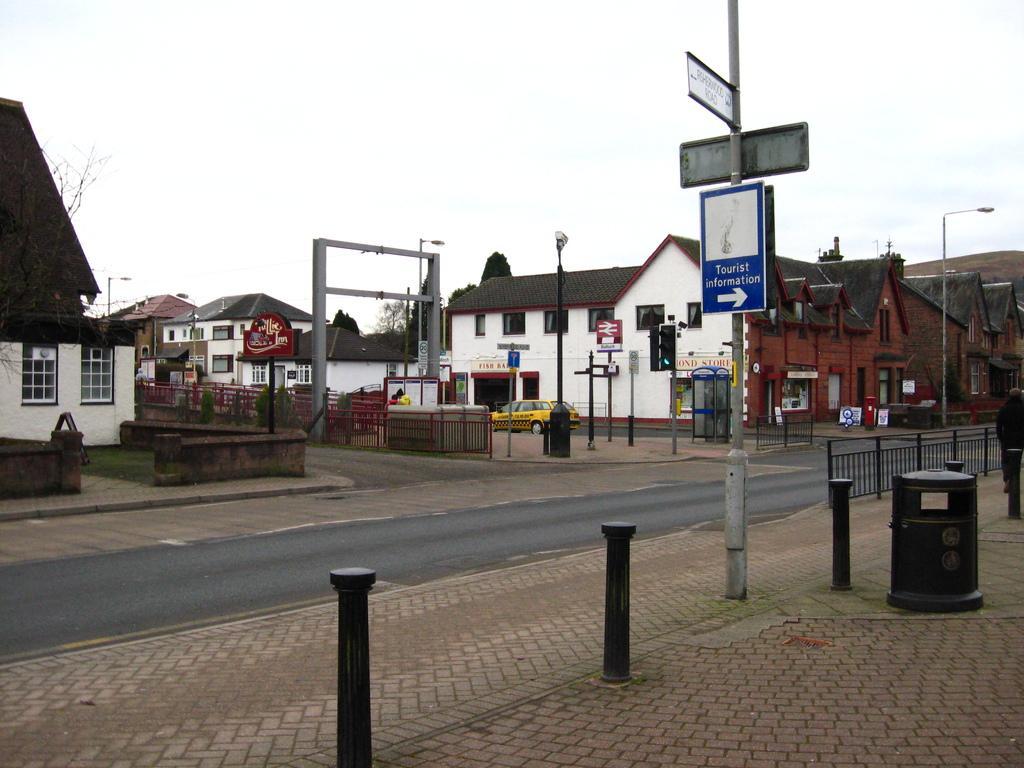In one or two sentences, can you explain what this image depicts? In this picture I can see the path in front, on which there are number of poles and I can see boards, on which there is something written. In the middle of this picture I can see number of buildings and few trees. I can also see the railings. In the background I can see the sky. On the right side of this image I can see a person. 